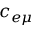<formula> <loc_0><loc_0><loc_500><loc_500>c _ { e \mu }</formula> 